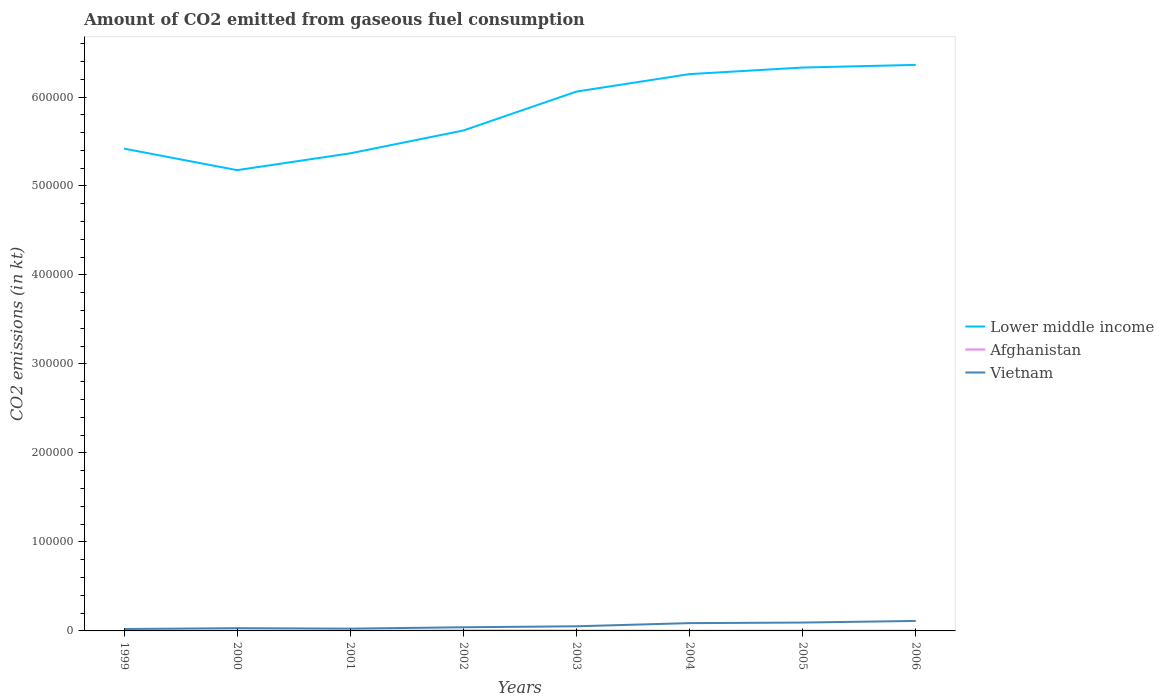How many different coloured lines are there?
Your answer should be compact. 3. Is the number of lines equal to the number of legend labels?
Your response must be concise. Yes. Across all years, what is the maximum amount of CO2 emitted in Afghanistan?
Provide a short and direct response. 209.02. In which year was the amount of CO2 emitted in Lower middle income maximum?
Make the answer very short. 2000. What is the total amount of CO2 emitted in Afghanistan in the graph?
Ensure brevity in your answer.  238.35. What is the difference between the highest and the second highest amount of CO2 emitted in Vietnam?
Provide a short and direct response. 9061.16. Is the amount of CO2 emitted in Vietnam strictly greater than the amount of CO2 emitted in Afghanistan over the years?
Offer a very short reply. No. What is the difference between two consecutive major ticks on the Y-axis?
Keep it short and to the point. 1.00e+05. Where does the legend appear in the graph?
Keep it short and to the point. Center right. How are the legend labels stacked?
Your response must be concise. Vertical. What is the title of the graph?
Offer a very short reply. Amount of CO2 emitted from gaseous fuel consumption. Does "Lithuania" appear as one of the legend labels in the graph?
Offer a terse response. No. What is the label or title of the X-axis?
Your response must be concise. Years. What is the label or title of the Y-axis?
Make the answer very short. CO2 emissions (in kt). What is the CO2 emissions (in kt) of Lower middle income in 1999?
Your response must be concise. 5.42e+05. What is the CO2 emissions (in kt) in Afghanistan in 1999?
Offer a terse response. 242.02. What is the CO2 emissions (in kt) in Vietnam in 1999?
Make the answer very short. 2159.86. What is the CO2 emissions (in kt) in Lower middle income in 2000?
Keep it short and to the point. 5.18e+05. What is the CO2 emissions (in kt) in Afghanistan in 2000?
Provide a succinct answer. 223.69. What is the CO2 emissions (in kt) of Vietnam in 2000?
Your answer should be very brief. 3065.61. What is the CO2 emissions (in kt) of Lower middle income in 2001?
Your answer should be very brief. 5.37e+05. What is the CO2 emissions (in kt) in Afghanistan in 2001?
Offer a very short reply. 209.02. What is the CO2 emissions (in kt) of Vietnam in 2001?
Provide a succinct answer. 2566.9. What is the CO2 emissions (in kt) in Lower middle income in 2002?
Provide a succinct answer. 5.62e+05. What is the CO2 emissions (in kt) in Afghanistan in 2002?
Provide a succinct answer. 546.38. What is the CO2 emissions (in kt) in Vietnam in 2002?
Ensure brevity in your answer.  4103.37. What is the CO2 emissions (in kt) of Lower middle income in 2003?
Offer a very short reply. 6.06e+05. What is the CO2 emissions (in kt) of Afghanistan in 2003?
Your answer should be very brief. 465.71. What is the CO2 emissions (in kt) of Vietnam in 2003?
Offer a terse response. 5210.81. What is the CO2 emissions (in kt) of Lower middle income in 2004?
Provide a succinct answer. 6.26e+05. What is the CO2 emissions (in kt) of Afghanistan in 2004?
Your answer should be compact. 227.35. What is the CO2 emissions (in kt) in Vietnam in 2004?
Offer a very short reply. 8767.8. What is the CO2 emissions (in kt) of Lower middle income in 2005?
Offer a terse response. 6.33e+05. What is the CO2 emissions (in kt) of Afghanistan in 2005?
Provide a short and direct response. 330.03. What is the CO2 emissions (in kt) in Vietnam in 2005?
Provide a short and direct response. 9402.19. What is the CO2 emissions (in kt) in Lower middle income in 2006?
Keep it short and to the point. 6.36e+05. What is the CO2 emissions (in kt) of Afghanistan in 2006?
Provide a short and direct response. 330.03. What is the CO2 emissions (in kt) in Vietnam in 2006?
Keep it short and to the point. 1.12e+04. Across all years, what is the maximum CO2 emissions (in kt) of Lower middle income?
Give a very brief answer. 6.36e+05. Across all years, what is the maximum CO2 emissions (in kt) in Afghanistan?
Offer a terse response. 546.38. Across all years, what is the maximum CO2 emissions (in kt) of Vietnam?
Your response must be concise. 1.12e+04. Across all years, what is the minimum CO2 emissions (in kt) of Lower middle income?
Make the answer very short. 5.18e+05. Across all years, what is the minimum CO2 emissions (in kt) in Afghanistan?
Your response must be concise. 209.02. Across all years, what is the minimum CO2 emissions (in kt) in Vietnam?
Your answer should be compact. 2159.86. What is the total CO2 emissions (in kt) in Lower middle income in the graph?
Provide a succinct answer. 4.66e+06. What is the total CO2 emissions (in kt) of Afghanistan in the graph?
Offer a terse response. 2574.23. What is the total CO2 emissions (in kt) of Vietnam in the graph?
Ensure brevity in your answer.  4.65e+04. What is the difference between the CO2 emissions (in kt) of Lower middle income in 1999 and that in 2000?
Make the answer very short. 2.42e+04. What is the difference between the CO2 emissions (in kt) of Afghanistan in 1999 and that in 2000?
Your answer should be very brief. 18.34. What is the difference between the CO2 emissions (in kt) of Vietnam in 1999 and that in 2000?
Ensure brevity in your answer.  -905.75. What is the difference between the CO2 emissions (in kt) in Lower middle income in 1999 and that in 2001?
Make the answer very short. 5295.58. What is the difference between the CO2 emissions (in kt) in Afghanistan in 1999 and that in 2001?
Provide a succinct answer. 33. What is the difference between the CO2 emissions (in kt) in Vietnam in 1999 and that in 2001?
Your answer should be very brief. -407.04. What is the difference between the CO2 emissions (in kt) in Lower middle income in 1999 and that in 2002?
Ensure brevity in your answer.  -2.04e+04. What is the difference between the CO2 emissions (in kt) in Afghanistan in 1999 and that in 2002?
Keep it short and to the point. -304.36. What is the difference between the CO2 emissions (in kt) in Vietnam in 1999 and that in 2002?
Offer a terse response. -1943.51. What is the difference between the CO2 emissions (in kt) of Lower middle income in 1999 and that in 2003?
Your answer should be very brief. -6.41e+04. What is the difference between the CO2 emissions (in kt) in Afghanistan in 1999 and that in 2003?
Provide a short and direct response. -223.69. What is the difference between the CO2 emissions (in kt) of Vietnam in 1999 and that in 2003?
Offer a very short reply. -3050.94. What is the difference between the CO2 emissions (in kt) in Lower middle income in 1999 and that in 2004?
Your response must be concise. -8.37e+04. What is the difference between the CO2 emissions (in kt) in Afghanistan in 1999 and that in 2004?
Provide a short and direct response. 14.67. What is the difference between the CO2 emissions (in kt) in Vietnam in 1999 and that in 2004?
Provide a succinct answer. -6607.93. What is the difference between the CO2 emissions (in kt) in Lower middle income in 1999 and that in 2005?
Offer a terse response. -9.11e+04. What is the difference between the CO2 emissions (in kt) in Afghanistan in 1999 and that in 2005?
Offer a terse response. -88.01. What is the difference between the CO2 emissions (in kt) of Vietnam in 1999 and that in 2005?
Your answer should be very brief. -7242.32. What is the difference between the CO2 emissions (in kt) of Lower middle income in 1999 and that in 2006?
Ensure brevity in your answer.  -9.41e+04. What is the difference between the CO2 emissions (in kt) of Afghanistan in 1999 and that in 2006?
Your answer should be compact. -88.01. What is the difference between the CO2 emissions (in kt) in Vietnam in 1999 and that in 2006?
Keep it short and to the point. -9061.16. What is the difference between the CO2 emissions (in kt) in Lower middle income in 2000 and that in 2001?
Your answer should be compact. -1.89e+04. What is the difference between the CO2 emissions (in kt) in Afghanistan in 2000 and that in 2001?
Provide a short and direct response. 14.67. What is the difference between the CO2 emissions (in kt) in Vietnam in 2000 and that in 2001?
Provide a succinct answer. 498.71. What is the difference between the CO2 emissions (in kt) in Lower middle income in 2000 and that in 2002?
Your answer should be compact. -4.46e+04. What is the difference between the CO2 emissions (in kt) of Afghanistan in 2000 and that in 2002?
Your response must be concise. -322.7. What is the difference between the CO2 emissions (in kt) in Vietnam in 2000 and that in 2002?
Give a very brief answer. -1037.76. What is the difference between the CO2 emissions (in kt) of Lower middle income in 2000 and that in 2003?
Offer a very short reply. -8.83e+04. What is the difference between the CO2 emissions (in kt) of Afghanistan in 2000 and that in 2003?
Your answer should be compact. -242.02. What is the difference between the CO2 emissions (in kt) of Vietnam in 2000 and that in 2003?
Your answer should be compact. -2145.2. What is the difference between the CO2 emissions (in kt) in Lower middle income in 2000 and that in 2004?
Your answer should be compact. -1.08e+05. What is the difference between the CO2 emissions (in kt) in Afghanistan in 2000 and that in 2004?
Keep it short and to the point. -3.67. What is the difference between the CO2 emissions (in kt) of Vietnam in 2000 and that in 2004?
Ensure brevity in your answer.  -5702.19. What is the difference between the CO2 emissions (in kt) of Lower middle income in 2000 and that in 2005?
Offer a very short reply. -1.15e+05. What is the difference between the CO2 emissions (in kt) in Afghanistan in 2000 and that in 2005?
Provide a succinct answer. -106.34. What is the difference between the CO2 emissions (in kt) of Vietnam in 2000 and that in 2005?
Your answer should be very brief. -6336.58. What is the difference between the CO2 emissions (in kt) of Lower middle income in 2000 and that in 2006?
Keep it short and to the point. -1.18e+05. What is the difference between the CO2 emissions (in kt) in Afghanistan in 2000 and that in 2006?
Provide a short and direct response. -106.34. What is the difference between the CO2 emissions (in kt) in Vietnam in 2000 and that in 2006?
Ensure brevity in your answer.  -8155.41. What is the difference between the CO2 emissions (in kt) in Lower middle income in 2001 and that in 2002?
Your answer should be very brief. -2.57e+04. What is the difference between the CO2 emissions (in kt) of Afghanistan in 2001 and that in 2002?
Provide a short and direct response. -337.36. What is the difference between the CO2 emissions (in kt) in Vietnam in 2001 and that in 2002?
Your response must be concise. -1536.47. What is the difference between the CO2 emissions (in kt) in Lower middle income in 2001 and that in 2003?
Offer a terse response. -6.94e+04. What is the difference between the CO2 emissions (in kt) of Afghanistan in 2001 and that in 2003?
Give a very brief answer. -256.69. What is the difference between the CO2 emissions (in kt) in Vietnam in 2001 and that in 2003?
Keep it short and to the point. -2643.91. What is the difference between the CO2 emissions (in kt) in Lower middle income in 2001 and that in 2004?
Offer a very short reply. -8.90e+04. What is the difference between the CO2 emissions (in kt) in Afghanistan in 2001 and that in 2004?
Make the answer very short. -18.34. What is the difference between the CO2 emissions (in kt) in Vietnam in 2001 and that in 2004?
Give a very brief answer. -6200.9. What is the difference between the CO2 emissions (in kt) in Lower middle income in 2001 and that in 2005?
Your answer should be very brief. -9.64e+04. What is the difference between the CO2 emissions (in kt) in Afghanistan in 2001 and that in 2005?
Offer a terse response. -121.01. What is the difference between the CO2 emissions (in kt) of Vietnam in 2001 and that in 2005?
Your answer should be compact. -6835.29. What is the difference between the CO2 emissions (in kt) of Lower middle income in 2001 and that in 2006?
Provide a short and direct response. -9.94e+04. What is the difference between the CO2 emissions (in kt) in Afghanistan in 2001 and that in 2006?
Your response must be concise. -121.01. What is the difference between the CO2 emissions (in kt) of Vietnam in 2001 and that in 2006?
Offer a terse response. -8654.12. What is the difference between the CO2 emissions (in kt) of Lower middle income in 2002 and that in 2003?
Offer a very short reply. -4.37e+04. What is the difference between the CO2 emissions (in kt) of Afghanistan in 2002 and that in 2003?
Provide a short and direct response. 80.67. What is the difference between the CO2 emissions (in kt) of Vietnam in 2002 and that in 2003?
Your response must be concise. -1107.43. What is the difference between the CO2 emissions (in kt) of Lower middle income in 2002 and that in 2004?
Ensure brevity in your answer.  -6.34e+04. What is the difference between the CO2 emissions (in kt) in Afghanistan in 2002 and that in 2004?
Give a very brief answer. 319.03. What is the difference between the CO2 emissions (in kt) in Vietnam in 2002 and that in 2004?
Provide a succinct answer. -4664.42. What is the difference between the CO2 emissions (in kt) of Lower middle income in 2002 and that in 2005?
Keep it short and to the point. -7.08e+04. What is the difference between the CO2 emissions (in kt) of Afghanistan in 2002 and that in 2005?
Offer a terse response. 216.35. What is the difference between the CO2 emissions (in kt) in Vietnam in 2002 and that in 2005?
Give a very brief answer. -5298.81. What is the difference between the CO2 emissions (in kt) in Lower middle income in 2002 and that in 2006?
Your response must be concise. -7.38e+04. What is the difference between the CO2 emissions (in kt) of Afghanistan in 2002 and that in 2006?
Give a very brief answer. 216.35. What is the difference between the CO2 emissions (in kt) of Vietnam in 2002 and that in 2006?
Your answer should be compact. -7117.65. What is the difference between the CO2 emissions (in kt) in Lower middle income in 2003 and that in 2004?
Offer a very short reply. -1.96e+04. What is the difference between the CO2 emissions (in kt) in Afghanistan in 2003 and that in 2004?
Your answer should be very brief. 238.35. What is the difference between the CO2 emissions (in kt) in Vietnam in 2003 and that in 2004?
Make the answer very short. -3556.99. What is the difference between the CO2 emissions (in kt) of Lower middle income in 2003 and that in 2005?
Give a very brief answer. -2.70e+04. What is the difference between the CO2 emissions (in kt) in Afghanistan in 2003 and that in 2005?
Your answer should be very brief. 135.68. What is the difference between the CO2 emissions (in kt) of Vietnam in 2003 and that in 2005?
Offer a very short reply. -4191.38. What is the difference between the CO2 emissions (in kt) in Lower middle income in 2003 and that in 2006?
Your response must be concise. -3.00e+04. What is the difference between the CO2 emissions (in kt) in Afghanistan in 2003 and that in 2006?
Provide a short and direct response. 135.68. What is the difference between the CO2 emissions (in kt) in Vietnam in 2003 and that in 2006?
Your response must be concise. -6010.21. What is the difference between the CO2 emissions (in kt) in Lower middle income in 2004 and that in 2005?
Provide a short and direct response. -7376.22. What is the difference between the CO2 emissions (in kt) of Afghanistan in 2004 and that in 2005?
Provide a short and direct response. -102.68. What is the difference between the CO2 emissions (in kt) of Vietnam in 2004 and that in 2005?
Your response must be concise. -634.39. What is the difference between the CO2 emissions (in kt) of Lower middle income in 2004 and that in 2006?
Make the answer very short. -1.04e+04. What is the difference between the CO2 emissions (in kt) in Afghanistan in 2004 and that in 2006?
Give a very brief answer. -102.68. What is the difference between the CO2 emissions (in kt) of Vietnam in 2004 and that in 2006?
Ensure brevity in your answer.  -2453.22. What is the difference between the CO2 emissions (in kt) of Lower middle income in 2005 and that in 2006?
Offer a terse response. -3003.93. What is the difference between the CO2 emissions (in kt) in Afghanistan in 2005 and that in 2006?
Keep it short and to the point. 0. What is the difference between the CO2 emissions (in kt) in Vietnam in 2005 and that in 2006?
Keep it short and to the point. -1818.83. What is the difference between the CO2 emissions (in kt) of Lower middle income in 1999 and the CO2 emissions (in kt) of Afghanistan in 2000?
Ensure brevity in your answer.  5.42e+05. What is the difference between the CO2 emissions (in kt) in Lower middle income in 1999 and the CO2 emissions (in kt) in Vietnam in 2000?
Provide a short and direct response. 5.39e+05. What is the difference between the CO2 emissions (in kt) of Afghanistan in 1999 and the CO2 emissions (in kt) of Vietnam in 2000?
Offer a terse response. -2823.59. What is the difference between the CO2 emissions (in kt) of Lower middle income in 1999 and the CO2 emissions (in kt) of Afghanistan in 2001?
Give a very brief answer. 5.42e+05. What is the difference between the CO2 emissions (in kt) in Lower middle income in 1999 and the CO2 emissions (in kt) in Vietnam in 2001?
Offer a terse response. 5.39e+05. What is the difference between the CO2 emissions (in kt) in Afghanistan in 1999 and the CO2 emissions (in kt) in Vietnam in 2001?
Offer a terse response. -2324.88. What is the difference between the CO2 emissions (in kt) of Lower middle income in 1999 and the CO2 emissions (in kt) of Afghanistan in 2002?
Give a very brief answer. 5.41e+05. What is the difference between the CO2 emissions (in kt) in Lower middle income in 1999 and the CO2 emissions (in kt) in Vietnam in 2002?
Your answer should be very brief. 5.38e+05. What is the difference between the CO2 emissions (in kt) in Afghanistan in 1999 and the CO2 emissions (in kt) in Vietnam in 2002?
Keep it short and to the point. -3861.35. What is the difference between the CO2 emissions (in kt) in Lower middle income in 1999 and the CO2 emissions (in kt) in Afghanistan in 2003?
Your answer should be compact. 5.42e+05. What is the difference between the CO2 emissions (in kt) in Lower middle income in 1999 and the CO2 emissions (in kt) in Vietnam in 2003?
Make the answer very short. 5.37e+05. What is the difference between the CO2 emissions (in kt) in Afghanistan in 1999 and the CO2 emissions (in kt) in Vietnam in 2003?
Offer a terse response. -4968.78. What is the difference between the CO2 emissions (in kt) in Lower middle income in 1999 and the CO2 emissions (in kt) in Afghanistan in 2004?
Make the answer very short. 5.42e+05. What is the difference between the CO2 emissions (in kt) in Lower middle income in 1999 and the CO2 emissions (in kt) in Vietnam in 2004?
Your answer should be very brief. 5.33e+05. What is the difference between the CO2 emissions (in kt) of Afghanistan in 1999 and the CO2 emissions (in kt) of Vietnam in 2004?
Give a very brief answer. -8525.77. What is the difference between the CO2 emissions (in kt) in Lower middle income in 1999 and the CO2 emissions (in kt) in Afghanistan in 2005?
Offer a very short reply. 5.42e+05. What is the difference between the CO2 emissions (in kt) in Lower middle income in 1999 and the CO2 emissions (in kt) in Vietnam in 2005?
Keep it short and to the point. 5.33e+05. What is the difference between the CO2 emissions (in kt) of Afghanistan in 1999 and the CO2 emissions (in kt) of Vietnam in 2005?
Keep it short and to the point. -9160.17. What is the difference between the CO2 emissions (in kt) in Lower middle income in 1999 and the CO2 emissions (in kt) in Afghanistan in 2006?
Give a very brief answer. 5.42e+05. What is the difference between the CO2 emissions (in kt) in Lower middle income in 1999 and the CO2 emissions (in kt) in Vietnam in 2006?
Your answer should be compact. 5.31e+05. What is the difference between the CO2 emissions (in kt) of Afghanistan in 1999 and the CO2 emissions (in kt) of Vietnam in 2006?
Your response must be concise. -1.10e+04. What is the difference between the CO2 emissions (in kt) of Lower middle income in 2000 and the CO2 emissions (in kt) of Afghanistan in 2001?
Your answer should be compact. 5.18e+05. What is the difference between the CO2 emissions (in kt) of Lower middle income in 2000 and the CO2 emissions (in kt) of Vietnam in 2001?
Ensure brevity in your answer.  5.15e+05. What is the difference between the CO2 emissions (in kt) of Afghanistan in 2000 and the CO2 emissions (in kt) of Vietnam in 2001?
Make the answer very short. -2343.21. What is the difference between the CO2 emissions (in kt) in Lower middle income in 2000 and the CO2 emissions (in kt) in Afghanistan in 2002?
Offer a terse response. 5.17e+05. What is the difference between the CO2 emissions (in kt) of Lower middle income in 2000 and the CO2 emissions (in kt) of Vietnam in 2002?
Your answer should be very brief. 5.14e+05. What is the difference between the CO2 emissions (in kt) of Afghanistan in 2000 and the CO2 emissions (in kt) of Vietnam in 2002?
Ensure brevity in your answer.  -3879.69. What is the difference between the CO2 emissions (in kt) in Lower middle income in 2000 and the CO2 emissions (in kt) in Afghanistan in 2003?
Offer a terse response. 5.17e+05. What is the difference between the CO2 emissions (in kt) of Lower middle income in 2000 and the CO2 emissions (in kt) of Vietnam in 2003?
Offer a very short reply. 5.13e+05. What is the difference between the CO2 emissions (in kt) in Afghanistan in 2000 and the CO2 emissions (in kt) in Vietnam in 2003?
Your response must be concise. -4987.12. What is the difference between the CO2 emissions (in kt) of Lower middle income in 2000 and the CO2 emissions (in kt) of Afghanistan in 2004?
Give a very brief answer. 5.18e+05. What is the difference between the CO2 emissions (in kt) of Lower middle income in 2000 and the CO2 emissions (in kt) of Vietnam in 2004?
Your response must be concise. 5.09e+05. What is the difference between the CO2 emissions (in kt) in Afghanistan in 2000 and the CO2 emissions (in kt) in Vietnam in 2004?
Ensure brevity in your answer.  -8544.11. What is the difference between the CO2 emissions (in kt) in Lower middle income in 2000 and the CO2 emissions (in kt) in Afghanistan in 2005?
Your response must be concise. 5.17e+05. What is the difference between the CO2 emissions (in kt) of Lower middle income in 2000 and the CO2 emissions (in kt) of Vietnam in 2005?
Give a very brief answer. 5.08e+05. What is the difference between the CO2 emissions (in kt) in Afghanistan in 2000 and the CO2 emissions (in kt) in Vietnam in 2005?
Ensure brevity in your answer.  -9178.5. What is the difference between the CO2 emissions (in kt) in Lower middle income in 2000 and the CO2 emissions (in kt) in Afghanistan in 2006?
Provide a short and direct response. 5.17e+05. What is the difference between the CO2 emissions (in kt) in Lower middle income in 2000 and the CO2 emissions (in kt) in Vietnam in 2006?
Keep it short and to the point. 5.07e+05. What is the difference between the CO2 emissions (in kt) of Afghanistan in 2000 and the CO2 emissions (in kt) of Vietnam in 2006?
Your response must be concise. -1.10e+04. What is the difference between the CO2 emissions (in kt) in Lower middle income in 2001 and the CO2 emissions (in kt) in Afghanistan in 2002?
Provide a succinct answer. 5.36e+05. What is the difference between the CO2 emissions (in kt) in Lower middle income in 2001 and the CO2 emissions (in kt) in Vietnam in 2002?
Your answer should be compact. 5.33e+05. What is the difference between the CO2 emissions (in kt) of Afghanistan in 2001 and the CO2 emissions (in kt) of Vietnam in 2002?
Give a very brief answer. -3894.35. What is the difference between the CO2 emissions (in kt) in Lower middle income in 2001 and the CO2 emissions (in kt) in Afghanistan in 2003?
Your answer should be very brief. 5.36e+05. What is the difference between the CO2 emissions (in kt) of Lower middle income in 2001 and the CO2 emissions (in kt) of Vietnam in 2003?
Ensure brevity in your answer.  5.31e+05. What is the difference between the CO2 emissions (in kt) in Afghanistan in 2001 and the CO2 emissions (in kt) in Vietnam in 2003?
Offer a very short reply. -5001.79. What is the difference between the CO2 emissions (in kt) of Lower middle income in 2001 and the CO2 emissions (in kt) of Afghanistan in 2004?
Your response must be concise. 5.36e+05. What is the difference between the CO2 emissions (in kt) in Lower middle income in 2001 and the CO2 emissions (in kt) in Vietnam in 2004?
Provide a succinct answer. 5.28e+05. What is the difference between the CO2 emissions (in kt) in Afghanistan in 2001 and the CO2 emissions (in kt) in Vietnam in 2004?
Your response must be concise. -8558.78. What is the difference between the CO2 emissions (in kt) of Lower middle income in 2001 and the CO2 emissions (in kt) of Afghanistan in 2005?
Ensure brevity in your answer.  5.36e+05. What is the difference between the CO2 emissions (in kt) of Lower middle income in 2001 and the CO2 emissions (in kt) of Vietnam in 2005?
Provide a succinct answer. 5.27e+05. What is the difference between the CO2 emissions (in kt) in Afghanistan in 2001 and the CO2 emissions (in kt) in Vietnam in 2005?
Your answer should be compact. -9193.17. What is the difference between the CO2 emissions (in kt) in Lower middle income in 2001 and the CO2 emissions (in kt) in Afghanistan in 2006?
Provide a short and direct response. 5.36e+05. What is the difference between the CO2 emissions (in kt) of Lower middle income in 2001 and the CO2 emissions (in kt) of Vietnam in 2006?
Provide a succinct answer. 5.25e+05. What is the difference between the CO2 emissions (in kt) of Afghanistan in 2001 and the CO2 emissions (in kt) of Vietnam in 2006?
Offer a very short reply. -1.10e+04. What is the difference between the CO2 emissions (in kt) of Lower middle income in 2002 and the CO2 emissions (in kt) of Afghanistan in 2003?
Your answer should be very brief. 5.62e+05. What is the difference between the CO2 emissions (in kt) in Lower middle income in 2002 and the CO2 emissions (in kt) in Vietnam in 2003?
Your answer should be very brief. 5.57e+05. What is the difference between the CO2 emissions (in kt) of Afghanistan in 2002 and the CO2 emissions (in kt) of Vietnam in 2003?
Ensure brevity in your answer.  -4664.42. What is the difference between the CO2 emissions (in kt) of Lower middle income in 2002 and the CO2 emissions (in kt) of Afghanistan in 2004?
Give a very brief answer. 5.62e+05. What is the difference between the CO2 emissions (in kt) in Lower middle income in 2002 and the CO2 emissions (in kt) in Vietnam in 2004?
Ensure brevity in your answer.  5.54e+05. What is the difference between the CO2 emissions (in kt) in Afghanistan in 2002 and the CO2 emissions (in kt) in Vietnam in 2004?
Ensure brevity in your answer.  -8221.41. What is the difference between the CO2 emissions (in kt) in Lower middle income in 2002 and the CO2 emissions (in kt) in Afghanistan in 2005?
Offer a very short reply. 5.62e+05. What is the difference between the CO2 emissions (in kt) in Lower middle income in 2002 and the CO2 emissions (in kt) in Vietnam in 2005?
Give a very brief answer. 5.53e+05. What is the difference between the CO2 emissions (in kt) in Afghanistan in 2002 and the CO2 emissions (in kt) in Vietnam in 2005?
Keep it short and to the point. -8855.81. What is the difference between the CO2 emissions (in kt) in Lower middle income in 2002 and the CO2 emissions (in kt) in Afghanistan in 2006?
Make the answer very short. 5.62e+05. What is the difference between the CO2 emissions (in kt) of Lower middle income in 2002 and the CO2 emissions (in kt) of Vietnam in 2006?
Provide a short and direct response. 5.51e+05. What is the difference between the CO2 emissions (in kt) of Afghanistan in 2002 and the CO2 emissions (in kt) of Vietnam in 2006?
Provide a short and direct response. -1.07e+04. What is the difference between the CO2 emissions (in kt) in Lower middle income in 2003 and the CO2 emissions (in kt) in Afghanistan in 2004?
Provide a succinct answer. 6.06e+05. What is the difference between the CO2 emissions (in kt) in Lower middle income in 2003 and the CO2 emissions (in kt) in Vietnam in 2004?
Ensure brevity in your answer.  5.97e+05. What is the difference between the CO2 emissions (in kt) of Afghanistan in 2003 and the CO2 emissions (in kt) of Vietnam in 2004?
Provide a short and direct response. -8302.09. What is the difference between the CO2 emissions (in kt) in Lower middle income in 2003 and the CO2 emissions (in kt) in Afghanistan in 2005?
Make the answer very short. 6.06e+05. What is the difference between the CO2 emissions (in kt) in Lower middle income in 2003 and the CO2 emissions (in kt) in Vietnam in 2005?
Keep it short and to the point. 5.97e+05. What is the difference between the CO2 emissions (in kt) in Afghanistan in 2003 and the CO2 emissions (in kt) in Vietnam in 2005?
Offer a terse response. -8936.48. What is the difference between the CO2 emissions (in kt) in Lower middle income in 2003 and the CO2 emissions (in kt) in Afghanistan in 2006?
Your answer should be compact. 6.06e+05. What is the difference between the CO2 emissions (in kt) in Lower middle income in 2003 and the CO2 emissions (in kt) in Vietnam in 2006?
Make the answer very short. 5.95e+05. What is the difference between the CO2 emissions (in kt) in Afghanistan in 2003 and the CO2 emissions (in kt) in Vietnam in 2006?
Provide a short and direct response. -1.08e+04. What is the difference between the CO2 emissions (in kt) of Lower middle income in 2004 and the CO2 emissions (in kt) of Afghanistan in 2005?
Your response must be concise. 6.25e+05. What is the difference between the CO2 emissions (in kt) of Lower middle income in 2004 and the CO2 emissions (in kt) of Vietnam in 2005?
Give a very brief answer. 6.16e+05. What is the difference between the CO2 emissions (in kt) in Afghanistan in 2004 and the CO2 emissions (in kt) in Vietnam in 2005?
Provide a succinct answer. -9174.83. What is the difference between the CO2 emissions (in kt) of Lower middle income in 2004 and the CO2 emissions (in kt) of Afghanistan in 2006?
Provide a succinct answer. 6.25e+05. What is the difference between the CO2 emissions (in kt) in Lower middle income in 2004 and the CO2 emissions (in kt) in Vietnam in 2006?
Make the answer very short. 6.15e+05. What is the difference between the CO2 emissions (in kt) in Afghanistan in 2004 and the CO2 emissions (in kt) in Vietnam in 2006?
Offer a terse response. -1.10e+04. What is the difference between the CO2 emissions (in kt) in Lower middle income in 2005 and the CO2 emissions (in kt) in Afghanistan in 2006?
Provide a short and direct response. 6.33e+05. What is the difference between the CO2 emissions (in kt) in Lower middle income in 2005 and the CO2 emissions (in kt) in Vietnam in 2006?
Make the answer very short. 6.22e+05. What is the difference between the CO2 emissions (in kt) of Afghanistan in 2005 and the CO2 emissions (in kt) of Vietnam in 2006?
Your answer should be compact. -1.09e+04. What is the average CO2 emissions (in kt) in Lower middle income per year?
Keep it short and to the point. 5.82e+05. What is the average CO2 emissions (in kt) of Afghanistan per year?
Your answer should be compact. 321.78. What is the average CO2 emissions (in kt) of Vietnam per year?
Provide a succinct answer. 5812.19. In the year 1999, what is the difference between the CO2 emissions (in kt) of Lower middle income and CO2 emissions (in kt) of Afghanistan?
Keep it short and to the point. 5.42e+05. In the year 1999, what is the difference between the CO2 emissions (in kt) in Lower middle income and CO2 emissions (in kt) in Vietnam?
Offer a very short reply. 5.40e+05. In the year 1999, what is the difference between the CO2 emissions (in kt) in Afghanistan and CO2 emissions (in kt) in Vietnam?
Your response must be concise. -1917.84. In the year 2000, what is the difference between the CO2 emissions (in kt) in Lower middle income and CO2 emissions (in kt) in Afghanistan?
Your response must be concise. 5.18e+05. In the year 2000, what is the difference between the CO2 emissions (in kt) in Lower middle income and CO2 emissions (in kt) in Vietnam?
Provide a succinct answer. 5.15e+05. In the year 2000, what is the difference between the CO2 emissions (in kt) in Afghanistan and CO2 emissions (in kt) in Vietnam?
Give a very brief answer. -2841.93. In the year 2001, what is the difference between the CO2 emissions (in kt) of Lower middle income and CO2 emissions (in kt) of Afghanistan?
Your answer should be very brief. 5.36e+05. In the year 2001, what is the difference between the CO2 emissions (in kt) in Lower middle income and CO2 emissions (in kt) in Vietnam?
Keep it short and to the point. 5.34e+05. In the year 2001, what is the difference between the CO2 emissions (in kt) of Afghanistan and CO2 emissions (in kt) of Vietnam?
Offer a terse response. -2357.88. In the year 2002, what is the difference between the CO2 emissions (in kt) in Lower middle income and CO2 emissions (in kt) in Afghanistan?
Your answer should be compact. 5.62e+05. In the year 2002, what is the difference between the CO2 emissions (in kt) of Lower middle income and CO2 emissions (in kt) of Vietnam?
Offer a very short reply. 5.58e+05. In the year 2002, what is the difference between the CO2 emissions (in kt) of Afghanistan and CO2 emissions (in kt) of Vietnam?
Offer a terse response. -3556.99. In the year 2003, what is the difference between the CO2 emissions (in kt) of Lower middle income and CO2 emissions (in kt) of Afghanistan?
Provide a short and direct response. 6.06e+05. In the year 2003, what is the difference between the CO2 emissions (in kt) of Lower middle income and CO2 emissions (in kt) of Vietnam?
Your answer should be compact. 6.01e+05. In the year 2003, what is the difference between the CO2 emissions (in kt) of Afghanistan and CO2 emissions (in kt) of Vietnam?
Your answer should be compact. -4745.1. In the year 2004, what is the difference between the CO2 emissions (in kt) in Lower middle income and CO2 emissions (in kt) in Afghanistan?
Provide a short and direct response. 6.26e+05. In the year 2004, what is the difference between the CO2 emissions (in kt) in Lower middle income and CO2 emissions (in kt) in Vietnam?
Your answer should be very brief. 6.17e+05. In the year 2004, what is the difference between the CO2 emissions (in kt) of Afghanistan and CO2 emissions (in kt) of Vietnam?
Your response must be concise. -8540.44. In the year 2005, what is the difference between the CO2 emissions (in kt) of Lower middle income and CO2 emissions (in kt) of Afghanistan?
Your answer should be compact. 6.33e+05. In the year 2005, what is the difference between the CO2 emissions (in kt) of Lower middle income and CO2 emissions (in kt) of Vietnam?
Your answer should be compact. 6.24e+05. In the year 2005, what is the difference between the CO2 emissions (in kt) in Afghanistan and CO2 emissions (in kt) in Vietnam?
Keep it short and to the point. -9072.16. In the year 2006, what is the difference between the CO2 emissions (in kt) in Lower middle income and CO2 emissions (in kt) in Afghanistan?
Give a very brief answer. 6.36e+05. In the year 2006, what is the difference between the CO2 emissions (in kt) in Lower middle income and CO2 emissions (in kt) in Vietnam?
Offer a very short reply. 6.25e+05. In the year 2006, what is the difference between the CO2 emissions (in kt) of Afghanistan and CO2 emissions (in kt) of Vietnam?
Ensure brevity in your answer.  -1.09e+04. What is the ratio of the CO2 emissions (in kt) of Lower middle income in 1999 to that in 2000?
Your answer should be very brief. 1.05. What is the ratio of the CO2 emissions (in kt) of Afghanistan in 1999 to that in 2000?
Offer a very short reply. 1.08. What is the ratio of the CO2 emissions (in kt) of Vietnam in 1999 to that in 2000?
Provide a short and direct response. 0.7. What is the ratio of the CO2 emissions (in kt) in Lower middle income in 1999 to that in 2001?
Offer a very short reply. 1.01. What is the ratio of the CO2 emissions (in kt) in Afghanistan in 1999 to that in 2001?
Your answer should be compact. 1.16. What is the ratio of the CO2 emissions (in kt) in Vietnam in 1999 to that in 2001?
Your response must be concise. 0.84. What is the ratio of the CO2 emissions (in kt) in Lower middle income in 1999 to that in 2002?
Provide a succinct answer. 0.96. What is the ratio of the CO2 emissions (in kt) of Afghanistan in 1999 to that in 2002?
Your answer should be very brief. 0.44. What is the ratio of the CO2 emissions (in kt) in Vietnam in 1999 to that in 2002?
Your answer should be compact. 0.53. What is the ratio of the CO2 emissions (in kt) in Lower middle income in 1999 to that in 2003?
Make the answer very short. 0.89. What is the ratio of the CO2 emissions (in kt) in Afghanistan in 1999 to that in 2003?
Offer a terse response. 0.52. What is the ratio of the CO2 emissions (in kt) in Vietnam in 1999 to that in 2003?
Provide a short and direct response. 0.41. What is the ratio of the CO2 emissions (in kt) of Lower middle income in 1999 to that in 2004?
Offer a terse response. 0.87. What is the ratio of the CO2 emissions (in kt) of Afghanistan in 1999 to that in 2004?
Give a very brief answer. 1.06. What is the ratio of the CO2 emissions (in kt) of Vietnam in 1999 to that in 2004?
Make the answer very short. 0.25. What is the ratio of the CO2 emissions (in kt) of Lower middle income in 1999 to that in 2005?
Keep it short and to the point. 0.86. What is the ratio of the CO2 emissions (in kt) of Afghanistan in 1999 to that in 2005?
Provide a short and direct response. 0.73. What is the ratio of the CO2 emissions (in kt) in Vietnam in 1999 to that in 2005?
Give a very brief answer. 0.23. What is the ratio of the CO2 emissions (in kt) in Lower middle income in 1999 to that in 2006?
Offer a terse response. 0.85. What is the ratio of the CO2 emissions (in kt) of Afghanistan in 1999 to that in 2006?
Your response must be concise. 0.73. What is the ratio of the CO2 emissions (in kt) of Vietnam in 1999 to that in 2006?
Keep it short and to the point. 0.19. What is the ratio of the CO2 emissions (in kt) in Lower middle income in 2000 to that in 2001?
Keep it short and to the point. 0.96. What is the ratio of the CO2 emissions (in kt) of Afghanistan in 2000 to that in 2001?
Your response must be concise. 1.07. What is the ratio of the CO2 emissions (in kt) of Vietnam in 2000 to that in 2001?
Give a very brief answer. 1.19. What is the ratio of the CO2 emissions (in kt) of Lower middle income in 2000 to that in 2002?
Offer a terse response. 0.92. What is the ratio of the CO2 emissions (in kt) in Afghanistan in 2000 to that in 2002?
Give a very brief answer. 0.41. What is the ratio of the CO2 emissions (in kt) of Vietnam in 2000 to that in 2002?
Your answer should be compact. 0.75. What is the ratio of the CO2 emissions (in kt) in Lower middle income in 2000 to that in 2003?
Your response must be concise. 0.85. What is the ratio of the CO2 emissions (in kt) of Afghanistan in 2000 to that in 2003?
Provide a succinct answer. 0.48. What is the ratio of the CO2 emissions (in kt) in Vietnam in 2000 to that in 2003?
Your answer should be compact. 0.59. What is the ratio of the CO2 emissions (in kt) of Lower middle income in 2000 to that in 2004?
Your answer should be compact. 0.83. What is the ratio of the CO2 emissions (in kt) in Afghanistan in 2000 to that in 2004?
Provide a succinct answer. 0.98. What is the ratio of the CO2 emissions (in kt) of Vietnam in 2000 to that in 2004?
Your response must be concise. 0.35. What is the ratio of the CO2 emissions (in kt) in Lower middle income in 2000 to that in 2005?
Your answer should be compact. 0.82. What is the ratio of the CO2 emissions (in kt) of Afghanistan in 2000 to that in 2005?
Give a very brief answer. 0.68. What is the ratio of the CO2 emissions (in kt) in Vietnam in 2000 to that in 2005?
Your answer should be compact. 0.33. What is the ratio of the CO2 emissions (in kt) of Lower middle income in 2000 to that in 2006?
Provide a succinct answer. 0.81. What is the ratio of the CO2 emissions (in kt) in Afghanistan in 2000 to that in 2006?
Your answer should be very brief. 0.68. What is the ratio of the CO2 emissions (in kt) of Vietnam in 2000 to that in 2006?
Offer a terse response. 0.27. What is the ratio of the CO2 emissions (in kt) in Lower middle income in 2001 to that in 2002?
Provide a succinct answer. 0.95. What is the ratio of the CO2 emissions (in kt) in Afghanistan in 2001 to that in 2002?
Provide a succinct answer. 0.38. What is the ratio of the CO2 emissions (in kt) in Vietnam in 2001 to that in 2002?
Ensure brevity in your answer.  0.63. What is the ratio of the CO2 emissions (in kt) in Lower middle income in 2001 to that in 2003?
Your answer should be compact. 0.89. What is the ratio of the CO2 emissions (in kt) of Afghanistan in 2001 to that in 2003?
Your answer should be very brief. 0.45. What is the ratio of the CO2 emissions (in kt) of Vietnam in 2001 to that in 2003?
Keep it short and to the point. 0.49. What is the ratio of the CO2 emissions (in kt) in Lower middle income in 2001 to that in 2004?
Make the answer very short. 0.86. What is the ratio of the CO2 emissions (in kt) in Afghanistan in 2001 to that in 2004?
Provide a short and direct response. 0.92. What is the ratio of the CO2 emissions (in kt) of Vietnam in 2001 to that in 2004?
Offer a terse response. 0.29. What is the ratio of the CO2 emissions (in kt) of Lower middle income in 2001 to that in 2005?
Keep it short and to the point. 0.85. What is the ratio of the CO2 emissions (in kt) of Afghanistan in 2001 to that in 2005?
Offer a very short reply. 0.63. What is the ratio of the CO2 emissions (in kt) of Vietnam in 2001 to that in 2005?
Your response must be concise. 0.27. What is the ratio of the CO2 emissions (in kt) in Lower middle income in 2001 to that in 2006?
Ensure brevity in your answer.  0.84. What is the ratio of the CO2 emissions (in kt) of Afghanistan in 2001 to that in 2006?
Make the answer very short. 0.63. What is the ratio of the CO2 emissions (in kt) in Vietnam in 2001 to that in 2006?
Offer a terse response. 0.23. What is the ratio of the CO2 emissions (in kt) of Lower middle income in 2002 to that in 2003?
Your response must be concise. 0.93. What is the ratio of the CO2 emissions (in kt) in Afghanistan in 2002 to that in 2003?
Provide a short and direct response. 1.17. What is the ratio of the CO2 emissions (in kt) of Vietnam in 2002 to that in 2003?
Keep it short and to the point. 0.79. What is the ratio of the CO2 emissions (in kt) of Lower middle income in 2002 to that in 2004?
Make the answer very short. 0.9. What is the ratio of the CO2 emissions (in kt) of Afghanistan in 2002 to that in 2004?
Your answer should be compact. 2.4. What is the ratio of the CO2 emissions (in kt) of Vietnam in 2002 to that in 2004?
Offer a very short reply. 0.47. What is the ratio of the CO2 emissions (in kt) of Lower middle income in 2002 to that in 2005?
Make the answer very short. 0.89. What is the ratio of the CO2 emissions (in kt) in Afghanistan in 2002 to that in 2005?
Provide a short and direct response. 1.66. What is the ratio of the CO2 emissions (in kt) in Vietnam in 2002 to that in 2005?
Ensure brevity in your answer.  0.44. What is the ratio of the CO2 emissions (in kt) of Lower middle income in 2002 to that in 2006?
Give a very brief answer. 0.88. What is the ratio of the CO2 emissions (in kt) of Afghanistan in 2002 to that in 2006?
Make the answer very short. 1.66. What is the ratio of the CO2 emissions (in kt) in Vietnam in 2002 to that in 2006?
Your response must be concise. 0.37. What is the ratio of the CO2 emissions (in kt) of Lower middle income in 2003 to that in 2004?
Keep it short and to the point. 0.97. What is the ratio of the CO2 emissions (in kt) of Afghanistan in 2003 to that in 2004?
Your response must be concise. 2.05. What is the ratio of the CO2 emissions (in kt) of Vietnam in 2003 to that in 2004?
Ensure brevity in your answer.  0.59. What is the ratio of the CO2 emissions (in kt) of Lower middle income in 2003 to that in 2005?
Provide a succinct answer. 0.96. What is the ratio of the CO2 emissions (in kt) in Afghanistan in 2003 to that in 2005?
Your response must be concise. 1.41. What is the ratio of the CO2 emissions (in kt) of Vietnam in 2003 to that in 2005?
Give a very brief answer. 0.55. What is the ratio of the CO2 emissions (in kt) of Lower middle income in 2003 to that in 2006?
Offer a terse response. 0.95. What is the ratio of the CO2 emissions (in kt) of Afghanistan in 2003 to that in 2006?
Keep it short and to the point. 1.41. What is the ratio of the CO2 emissions (in kt) in Vietnam in 2003 to that in 2006?
Your answer should be compact. 0.46. What is the ratio of the CO2 emissions (in kt) in Lower middle income in 2004 to that in 2005?
Your answer should be very brief. 0.99. What is the ratio of the CO2 emissions (in kt) in Afghanistan in 2004 to that in 2005?
Provide a short and direct response. 0.69. What is the ratio of the CO2 emissions (in kt) of Vietnam in 2004 to that in 2005?
Your answer should be very brief. 0.93. What is the ratio of the CO2 emissions (in kt) in Lower middle income in 2004 to that in 2006?
Offer a terse response. 0.98. What is the ratio of the CO2 emissions (in kt) of Afghanistan in 2004 to that in 2006?
Your answer should be compact. 0.69. What is the ratio of the CO2 emissions (in kt) of Vietnam in 2004 to that in 2006?
Ensure brevity in your answer.  0.78. What is the ratio of the CO2 emissions (in kt) of Lower middle income in 2005 to that in 2006?
Offer a terse response. 1. What is the ratio of the CO2 emissions (in kt) of Afghanistan in 2005 to that in 2006?
Make the answer very short. 1. What is the ratio of the CO2 emissions (in kt) in Vietnam in 2005 to that in 2006?
Keep it short and to the point. 0.84. What is the difference between the highest and the second highest CO2 emissions (in kt) in Lower middle income?
Your answer should be compact. 3003.93. What is the difference between the highest and the second highest CO2 emissions (in kt) of Afghanistan?
Ensure brevity in your answer.  80.67. What is the difference between the highest and the second highest CO2 emissions (in kt) of Vietnam?
Keep it short and to the point. 1818.83. What is the difference between the highest and the lowest CO2 emissions (in kt) of Lower middle income?
Provide a succinct answer. 1.18e+05. What is the difference between the highest and the lowest CO2 emissions (in kt) in Afghanistan?
Provide a succinct answer. 337.36. What is the difference between the highest and the lowest CO2 emissions (in kt) of Vietnam?
Make the answer very short. 9061.16. 